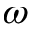Convert formula to latex. <formula><loc_0><loc_0><loc_500><loc_500>\omega</formula> 